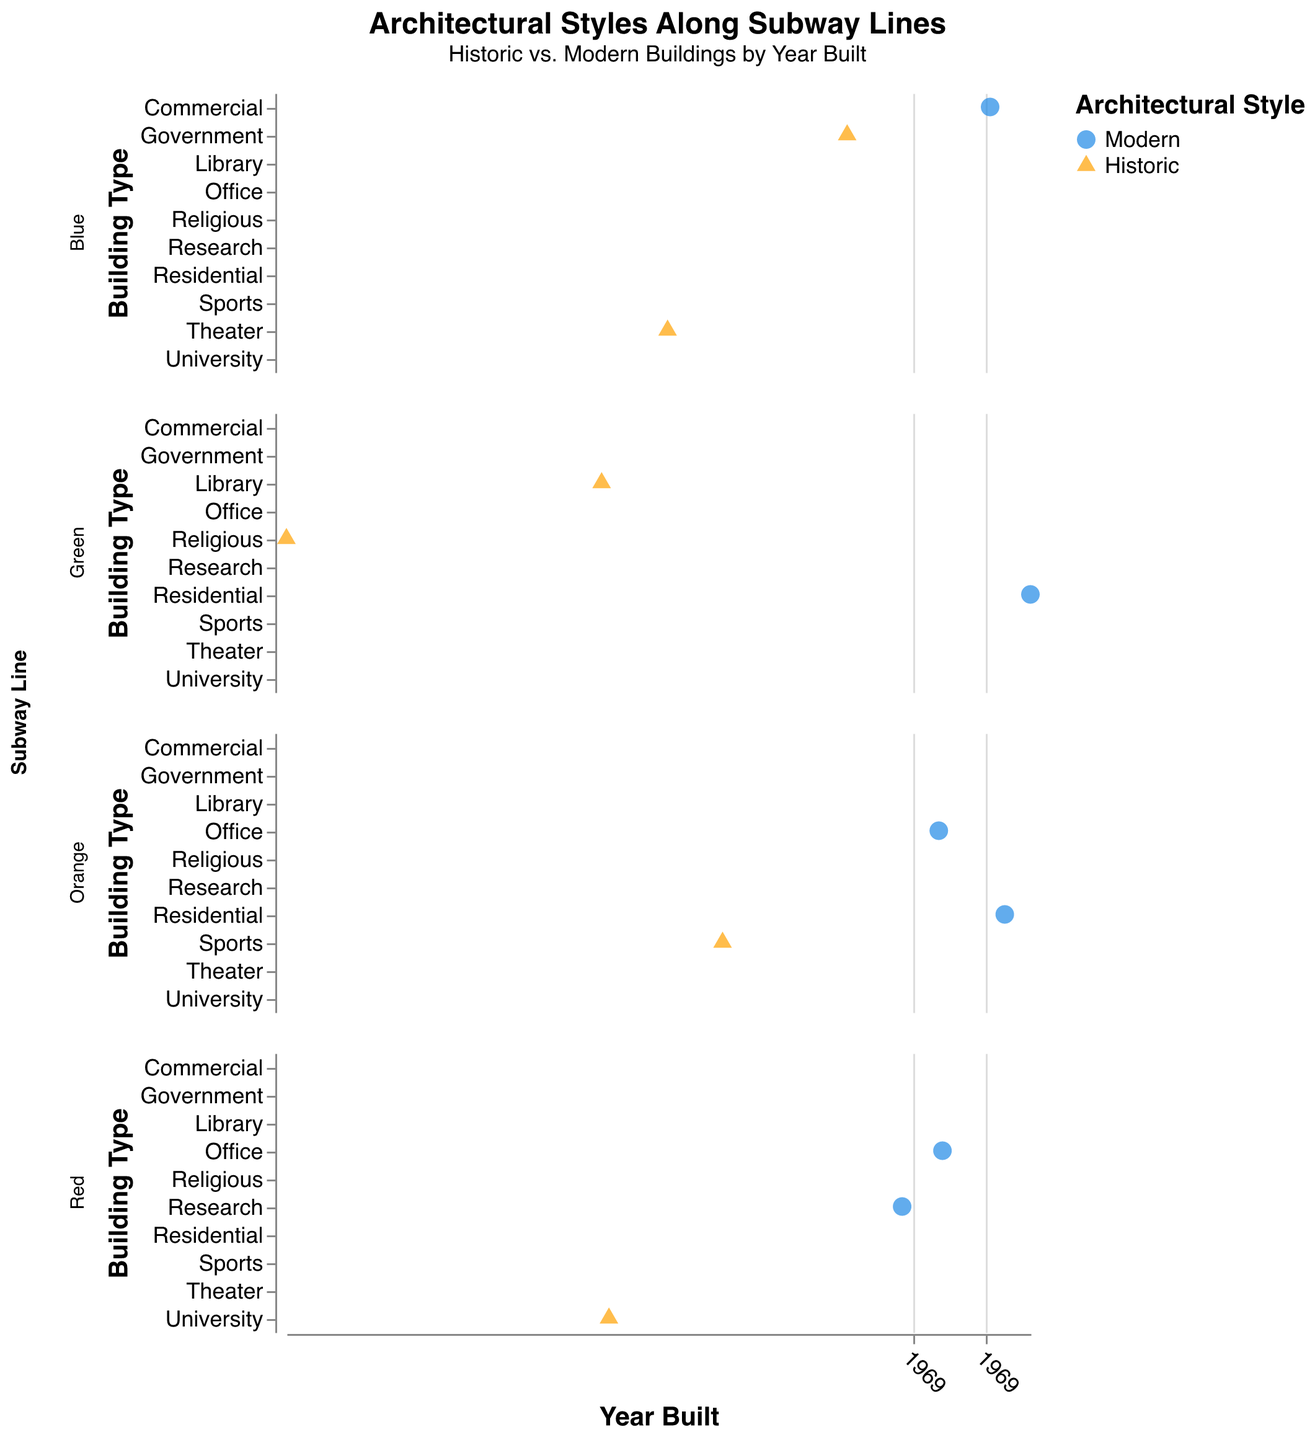How many historic buildings are there along the Blue Line? Count the triangles (representing historic buildings) in the subplot for the Blue Line
Answer: 2 Which subway line has the oldest building and what type is it? Look for the data point furthest to the left across all subplots and check its building type
Answer: Green Line, Religious What's the architectural style of Park Street station? Find the data point labeled "Park Street" and check its color or shape
Answer: Historic Compare the number of modern buildings between the Red Line and Orange Line. Which has more? Count the circles (representing modern buildings) in both the Red Line and Orange Line subplots and compare
Answer: Orange Line Which station along the Red Line was built in the 1970s? What type of building is it? Find the data point in the Red Line subplot that falls within the 1970s and check its corresponding station and building type
Answer: Kendall/MIT, Research Which subway line has the most diverse types of buildings by count? Count the number of distinct building types in each subplot and compare
Answer: Green Line For the Green Line, which stations were built in the 19th century and what's their architectural style? Identify the data points in the Green Line subplot that are in the 1800s and check their architectural style
Answer: Copley (Historic), Park Street (Historic) Are there any lines where all the stations have modern buildings? Check each subplot to see if all points are circles (modern buildings)
Answer: No Which modern building is the oldest and on which subway line? Find the earliest year among circles (modern buildings) across all subplots
Answer: Kendall/MIT, Red Line 